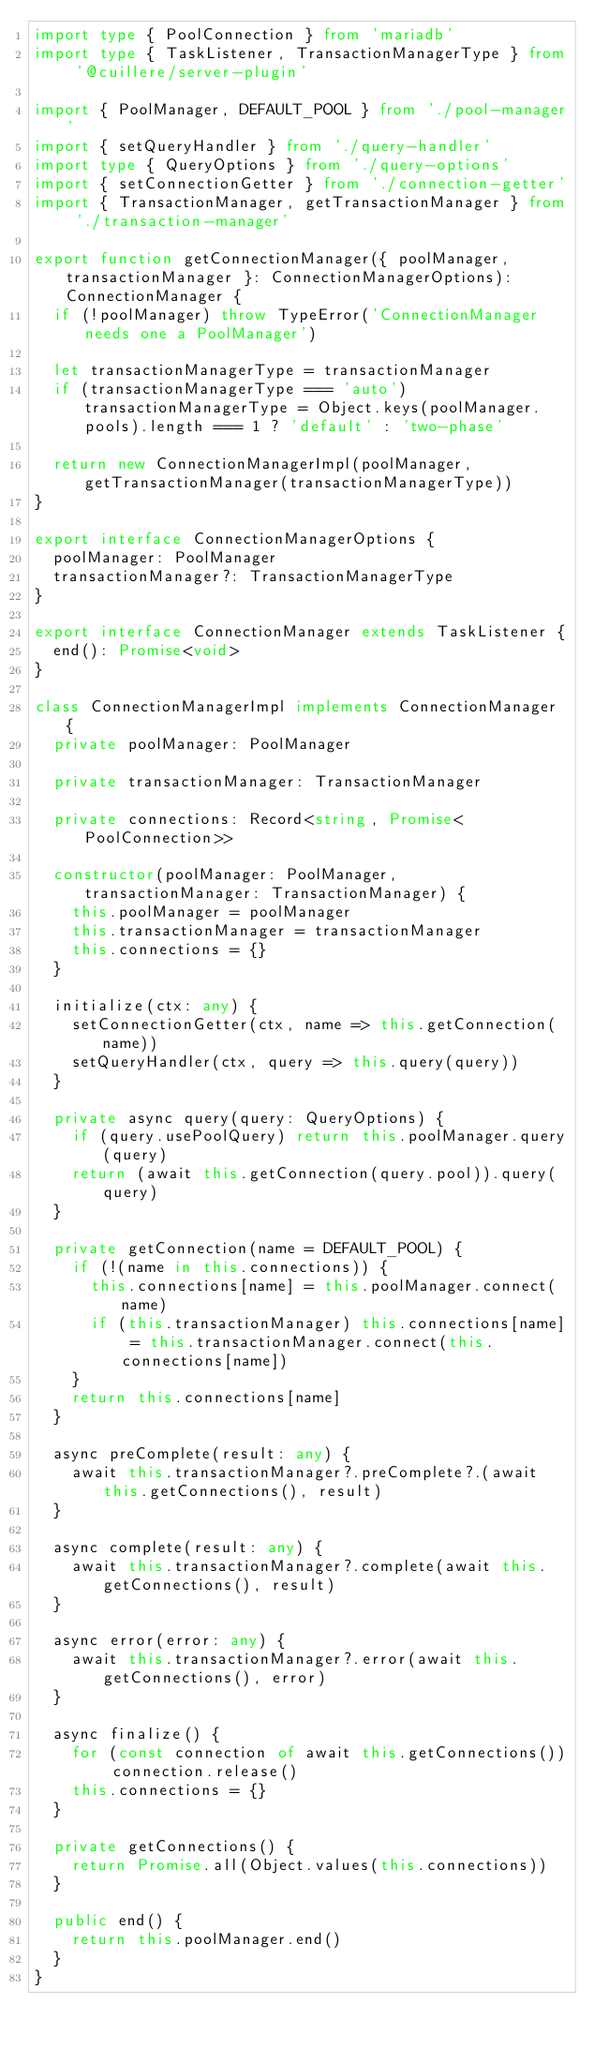Convert code to text. <code><loc_0><loc_0><loc_500><loc_500><_TypeScript_>import type { PoolConnection } from 'mariadb'
import type { TaskListener, TransactionManagerType } from '@cuillere/server-plugin'

import { PoolManager, DEFAULT_POOL } from './pool-manager'
import { setQueryHandler } from './query-handler'
import type { QueryOptions } from './query-options'
import { setConnectionGetter } from './connection-getter'
import { TransactionManager, getTransactionManager } from './transaction-manager'

export function getConnectionManager({ poolManager, transactionManager }: ConnectionManagerOptions): ConnectionManager {
  if (!poolManager) throw TypeError('ConnectionManager needs one a PoolManager')

  let transactionManagerType = transactionManager
  if (transactionManagerType === 'auto') transactionManagerType = Object.keys(poolManager.pools).length === 1 ? 'default' : 'two-phase'

  return new ConnectionManagerImpl(poolManager, getTransactionManager(transactionManagerType))
}

export interface ConnectionManagerOptions {
  poolManager: PoolManager
  transactionManager?: TransactionManagerType
}

export interface ConnectionManager extends TaskListener {
  end(): Promise<void>
}

class ConnectionManagerImpl implements ConnectionManager {
  private poolManager: PoolManager

  private transactionManager: TransactionManager

  private connections: Record<string, Promise<PoolConnection>>

  constructor(poolManager: PoolManager, transactionManager: TransactionManager) {
    this.poolManager = poolManager
    this.transactionManager = transactionManager
    this.connections = {}
  }

  initialize(ctx: any) {
    setConnectionGetter(ctx, name => this.getConnection(name))
    setQueryHandler(ctx, query => this.query(query))
  }

  private async query(query: QueryOptions) {
    if (query.usePoolQuery) return this.poolManager.query(query)
    return (await this.getConnection(query.pool)).query(query)
  }

  private getConnection(name = DEFAULT_POOL) {
    if (!(name in this.connections)) {
      this.connections[name] = this.poolManager.connect(name)
      if (this.transactionManager) this.connections[name] = this.transactionManager.connect(this.connections[name])
    }
    return this.connections[name]
  }

  async preComplete(result: any) {
    await this.transactionManager?.preComplete?.(await this.getConnections(), result)
  }

  async complete(result: any) {
    await this.transactionManager?.complete(await this.getConnections(), result)
  }

  async error(error: any) {
    await this.transactionManager?.error(await this.getConnections(), error)
  }

  async finalize() {
    for (const connection of await this.getConnections()) connection.release()
    this.connections = {}
  }

  private getConnections() {
    return Promise.all(Object.values(this.connections))
  }

  public end() {
    return this.poolManager.end()
  }
}
</code> 